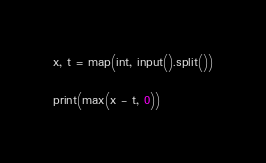Convert code to text. <code><loc_0><loc_0><loc_500><loc_500><_Python_>x, t = map(int, input().split())

print(max(x - t, 0))</code> 